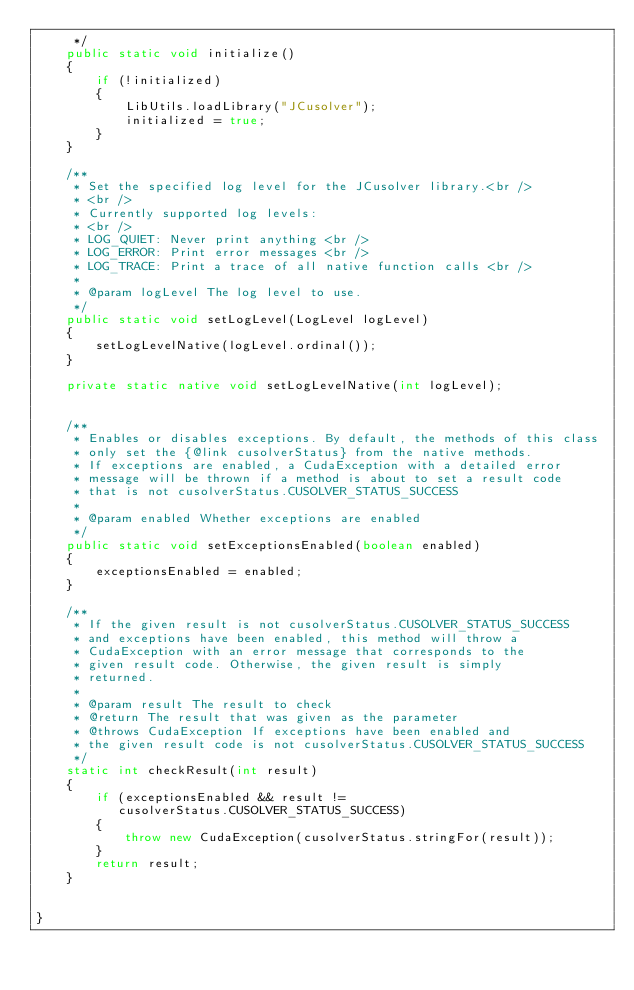<code> <loc_0><loc_0><loc_500><loc_500><_Java_>     */
    public static void initialize()
    {
        if (!initialized)
        {
            LibUtils.loadLibrary("JCusolver");
            initialized = true;
        }
    }

    /**
     * Set the specified log level for the JCusolver library.<br />
     * <br />
     * Currently supported log levels:
     * <br />
     * LOG_QUIET: Never print anything <br />
     * LOG_ERROR: Print error messages <br />
     * LOG_TRACE: Print a trace of all native function calls <br />
     *
     * @param logLevel The log level to use.
     */
    public static void setLogLevel(LogLevel logLevel)
    {
        setLogLevelNative(logLevel.ordinal());
    }

    private static native void setLogLevelNative(int logLevel);


    /**
     * Enables or disables exceptions. By default, the methods of this class
     * only set the {@link cusolverStatus} from the native methods. 
     * If exceptions are enabled, a CudaException with a detailed error 
     * message will be thrown if a method is about to set a result code 
     * that is not cusolverStatus.CUSOLVER_STATUS_SUCCESS
     * 
     * @param enabled Whether exceptions are enabled
     */
    public static void setExceptionsEnabled(boolean enabled)
    {
        exceptionsEnabled = enabled;
    }
    
    /**
     * If the given result is not cusolverStatus.CUSOLVER_STATUS_SUCCESS
     * and exceptions have been enabled, this method will throw a 
     * CudaException with an error message that corresponds to the
     * given result code. Otherwise, the given result is simply
     * returned.
     * 
     * @param result The result to check
     * @return The result that was given as the parameter
     * @throws CudaException If exceptions have been enabled and
     * the given result code is not cusolverStatus.CUSOLVER_STATUS_SUCCESS
     */
    static int checkResult(int result)
    {
        if (exceptionsEnabled && result != 
           cusolverStatus.CUSOLVER_STATUS_SUCCESS)
        {
            throw new CudaException(cusolverStatus.stringFor(result));
        }
        return result;
    }
    

}
</code> 